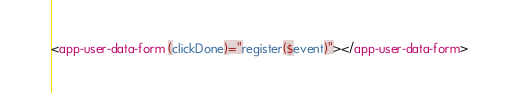<code> <loc_0><loc_0><loc_500><loc_500><_HTML_><app-user-data-form (clickDone)="register($event)"></app-user-data-form>
</code> 